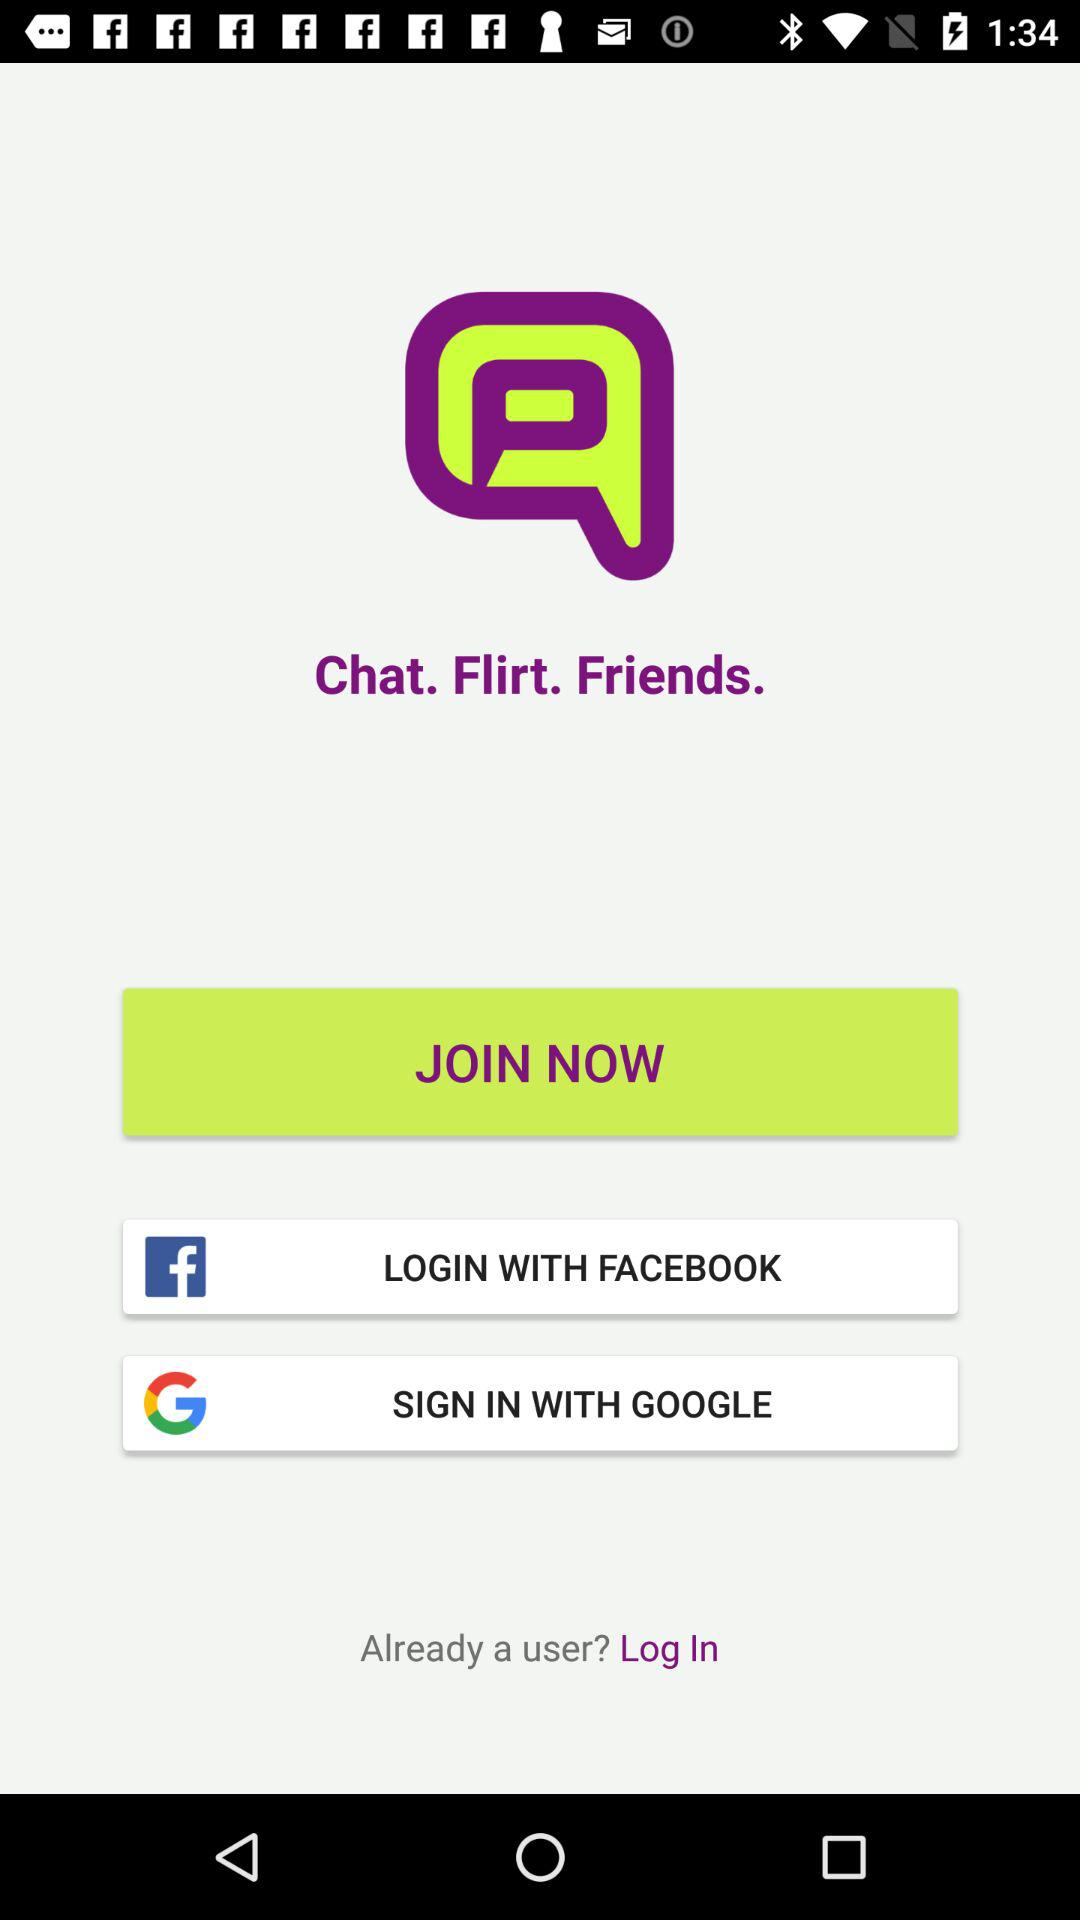What applications are used for login? The applications used for login are "FACEBOOK" and "GOOGLE". 